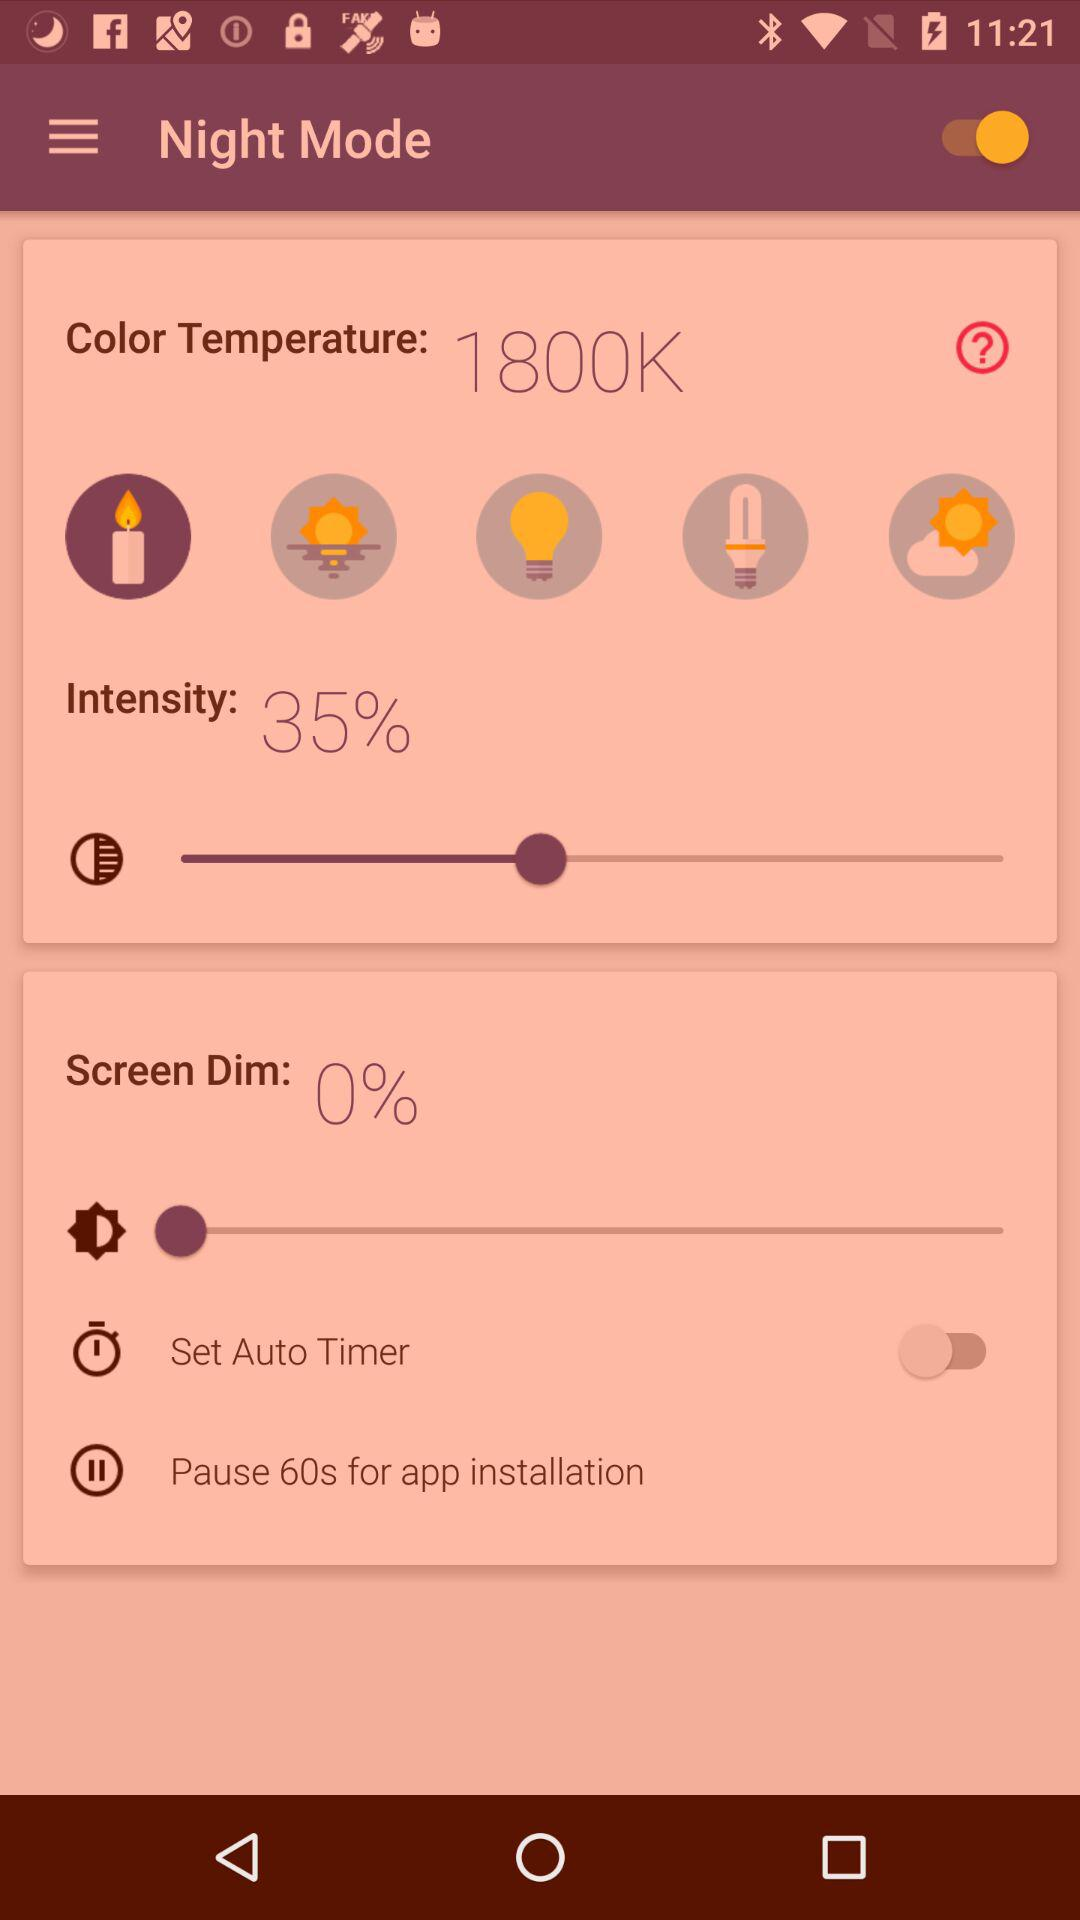How many seconds is the pause for application installation? The pause for application installation is 60 seconds. 